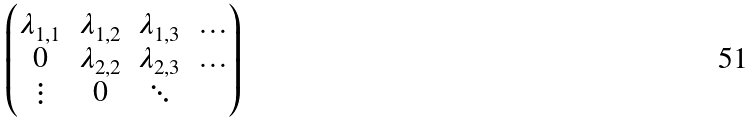Convert formula to latex. <formula><loc_0><loc_0><loc_500><loc_500>\begin{pmatrix} \lambda _ { 1 , 1 } & \lambda _ { 1 , 2 } & \lambda _ { 1 , 3 } & \dots \\ 0 & \lambda _ { 2 , 2 } & \lambda _ { 2 , 3 } & \dots \\ \vdots & 0 & \ddots \end{pmatrix}</formula> 